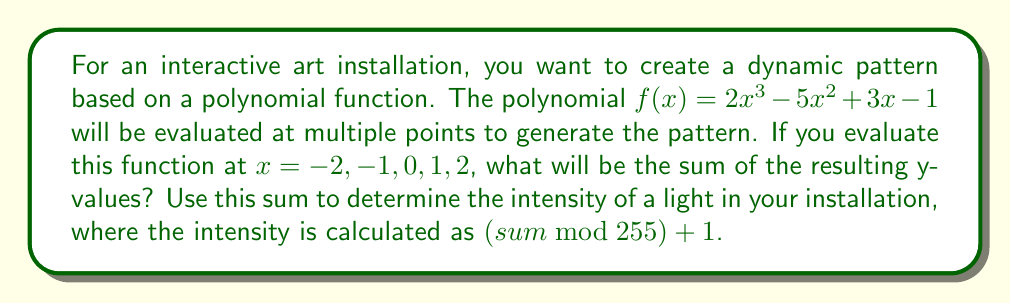Can you answer this question? To solve this problem, we need to follow these steps:

1) Evaluate the polynomial $f(x) = 2x^3 - 5x^2 + 3x - 1$ at each given x-value:

   For $x = -2$:
   $f(-2) = 2(-2)^3 - 5(-2)^2 + 3(-2) - 1$
   $= -16 - 20 - 6 - 1 = -43$

   For $x = -1$:
   $f(-1) = 2(-1)^3 - 5(-1)^2 + 3(-1) - 1$
   $= -2 - 5 - 3 - 1 = -11$

   For $x = 0$:
   $f(0) = 2(0)^3 - 5(0)^2 + 3(0) - 1 = -1$

   For $x = 1$:
   $f(1) = 2(1)^3 - 5(1)^2 + 3(1) - 1$
   $= 2 - 5 + 3 - 1 = -1$

   For $x = 2$:
   $f(2) = 2(2)^3 - 5(2)^2 + 3(2) - 1$
   $= 16 - 20 + 6 - 1 = 1$

2) Sum up all these y-values:
   $(-43) + (-11) + (-1) + (-1) + 1 = -55$

3) Calculate the light intensity:
   $intensity = (sum \bmod 255) + 1$
   $= (-55 \bmod 255) + 1$
   $= 200 + 1 = 201$

Note: In modular arithmetic, negative numbers wrap around. -55 mod 255 is equivalent to 200, as -55 + 255 = 200.
Answer: The sum of the y-values is -55, and the resulting light intensity for the installation is 201. 